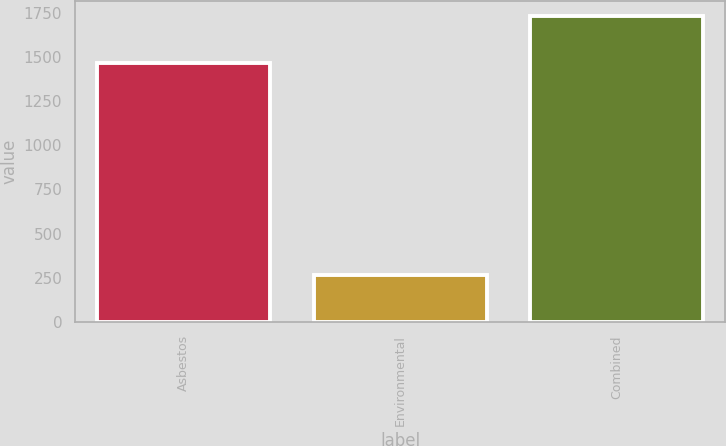<chart> <loc_0><loc_0><loc_500><loc_500><bar_chart><fcel>Asbestos<fcel>Environmental<fcel>Combined<nl><fcel>1465<fcel>266<fcel>1731<nl></chart> 